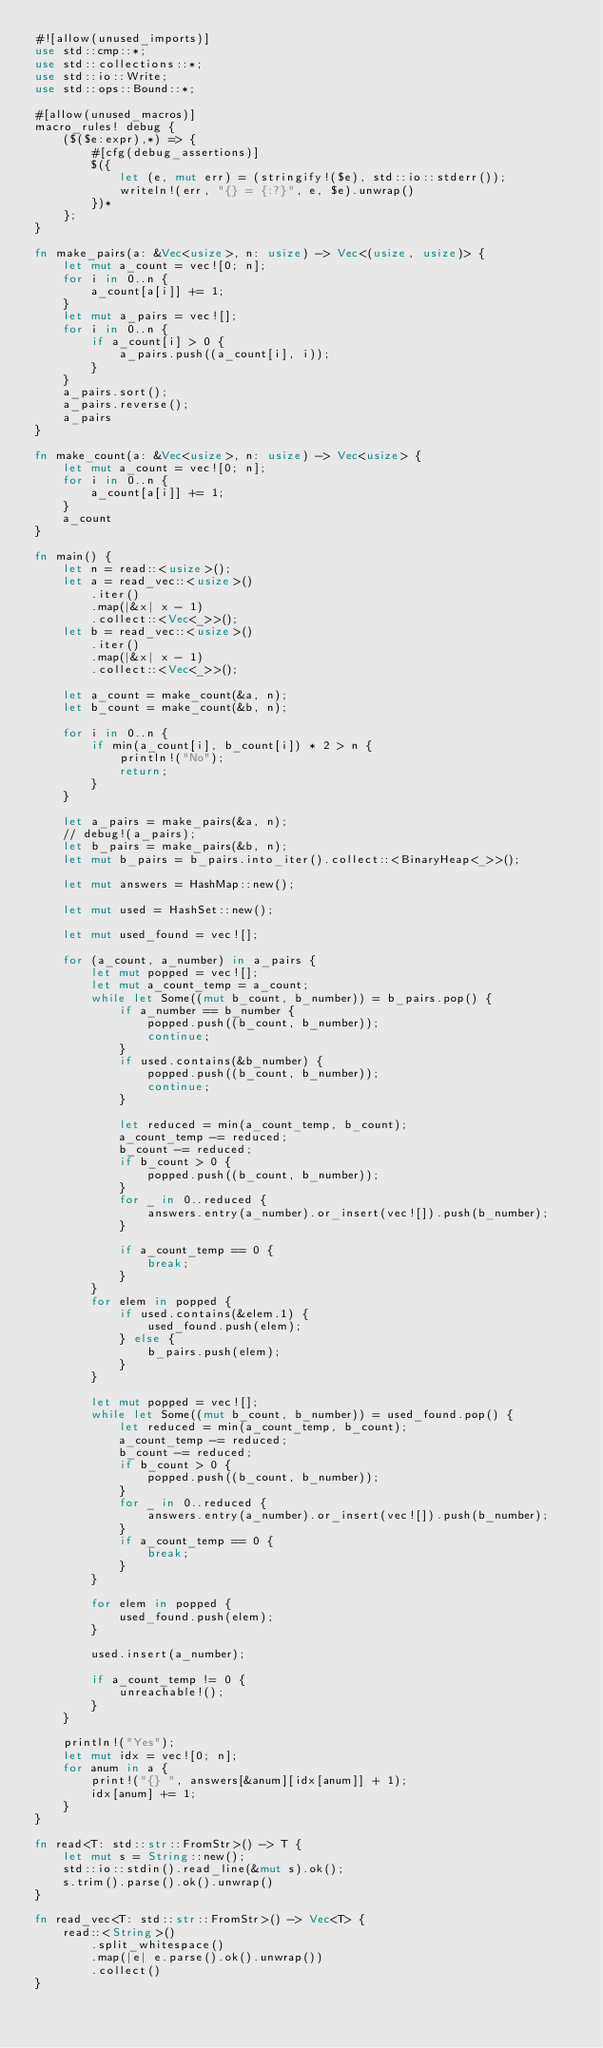<code> <loc_0><loc_0><loc_500><loc_500><_Rust_>#![allow(unused_imports)]
use std::cmp::*;
use std::collections::*;
use std::io::Write;
use std::ops::Bound::*;

#[allow(unused_macros)]
macro_rules! debug {
    ($($e:expr),*) => {
        #[cfg(debug_assertions)]
        $({
            let (e, mut err) = (stringify!($e), std::io::stderr());
            writeln!(err, "{} = {:?}", e, $e).unwrap()
        })*
    };
}

fn make_pairs(a: &Vec<usize>, n: usize) -> Vec<(usize, usize)> {
    let mut a_count = vec![0; n];
    for i in 0..n {
        a_count[a[i]] += 1;
    }
    let mut a_pairs = vec![];
    for i in 0..n {
        if a_count[i] > 0 {
            a_pairs.push((a_count[i], i));
        }
    }
    a_pairs.sort();
    a_pairs.reverse();
    a_pairs
}

fn make_count(a: &Vec<usize>, n: usize) -> Vec<usize> {
    let mut a_count = vec![0; n];
    for i in 0..n {
        a_count[a[i]] += 1;
    }
    a_count
}

fn main() {
    let n = read::<usize>();
    let a = read_vec::<usize>()
        .iter()
        .map(|&x| x - 1)
        .collect::<Vec<_>>();
    let b = read_vec::<usize>()
        .iter()
        .map(|&x| x - 1)
        .collect::<Vec<_>>();

    let a_count = make_count(&a, n);
    let b_count = make_count(&b, n);

    for i in 0..n {
        if min(a_count[i], b_count[i]) * 2 > n {
            println!("No");
            return;
        }
    }

    let a_pairs = make_pairs(&a, n);
    // debug!(a_pairs);
    let b_pairs = make_pairs(&b, n);
    let mut b_pairs = b_pairs.into_iter().collect::<BinaryHeap<_>>();

    let mut answers = HashMap::new();

    let mut used = HashSet::new();

    let mut used_found = vec![];

    for (a_count, a_number) in a_pairs {
        let mut popped = vec![];
        let mut a_count_temp = a_count;
        while let Some((mut b_count, b_number)) = b_pairs.pop() {
            if a_number == b_number {
                popped.push((b_count, b_number));
                continue;
            }
            if used.contains(&b_number) {
                popped.push((b_count, b_number));
                continue;
            }

            let reduced = min(a_count_temp, b_count);
            a_count_temp -= reduced;
            b_count -= reduced;
            if b_count > 0 {
                popped.push((b_count, b_number));
            }
            for _ in 0..reduced {
                answers.entry(a_number).or_insert(vec![]).push(b_number);
            }

            if a_count_temp == 0 {
                break;
            }
        }
        for elem in popped {
            if used.contains(&elem.1) {
                used_found.push(elem);
            } else {
                b_pairs.push(elem);
            }
        }

        let mut popped = vec![];
        while let Some((mut b_count, b_number)) = used_found.pop() {
            let reduced = min(a_count_temp, b_count);
            a_count_temp -= reduced;
            b_count -= reduced;
            if b_count > 0 {
                popped.push((b_count, b_number));
            }
            for _ in 0..reduced {
                answers.entry(a_number).or_insert(vec![]).push(b_number);
            }
            if a_count_temp == 0 {
                break;
            }
        }

        for elem in popped {
            used_found.push(elem);
        }

        used.insert(a_number);

        if a_count_temp != 0 {
            unreachable!();
        }
    }

    println!("Yes");
    let mut idx = vec![0; n];
    for anum in a {
        print!("{} ", answers[&anum][idx[anum]] + 1);
        idx[anum] += 1;
    }
}

fn read<T: std::str::FromStr>() -> T {
    let mut s = String::new();
    std::io::stdin().read_line(&mut s).ok();
    s.trim().parse().ok().unwrap()
}

fn read_vec<T: std::str::FromStr>() -> Vec<T> {
    read::<String>()
        .split_whitespace()
        .map(|e| e.parse().ok().unwrap())
        .collect()
}
</code> 